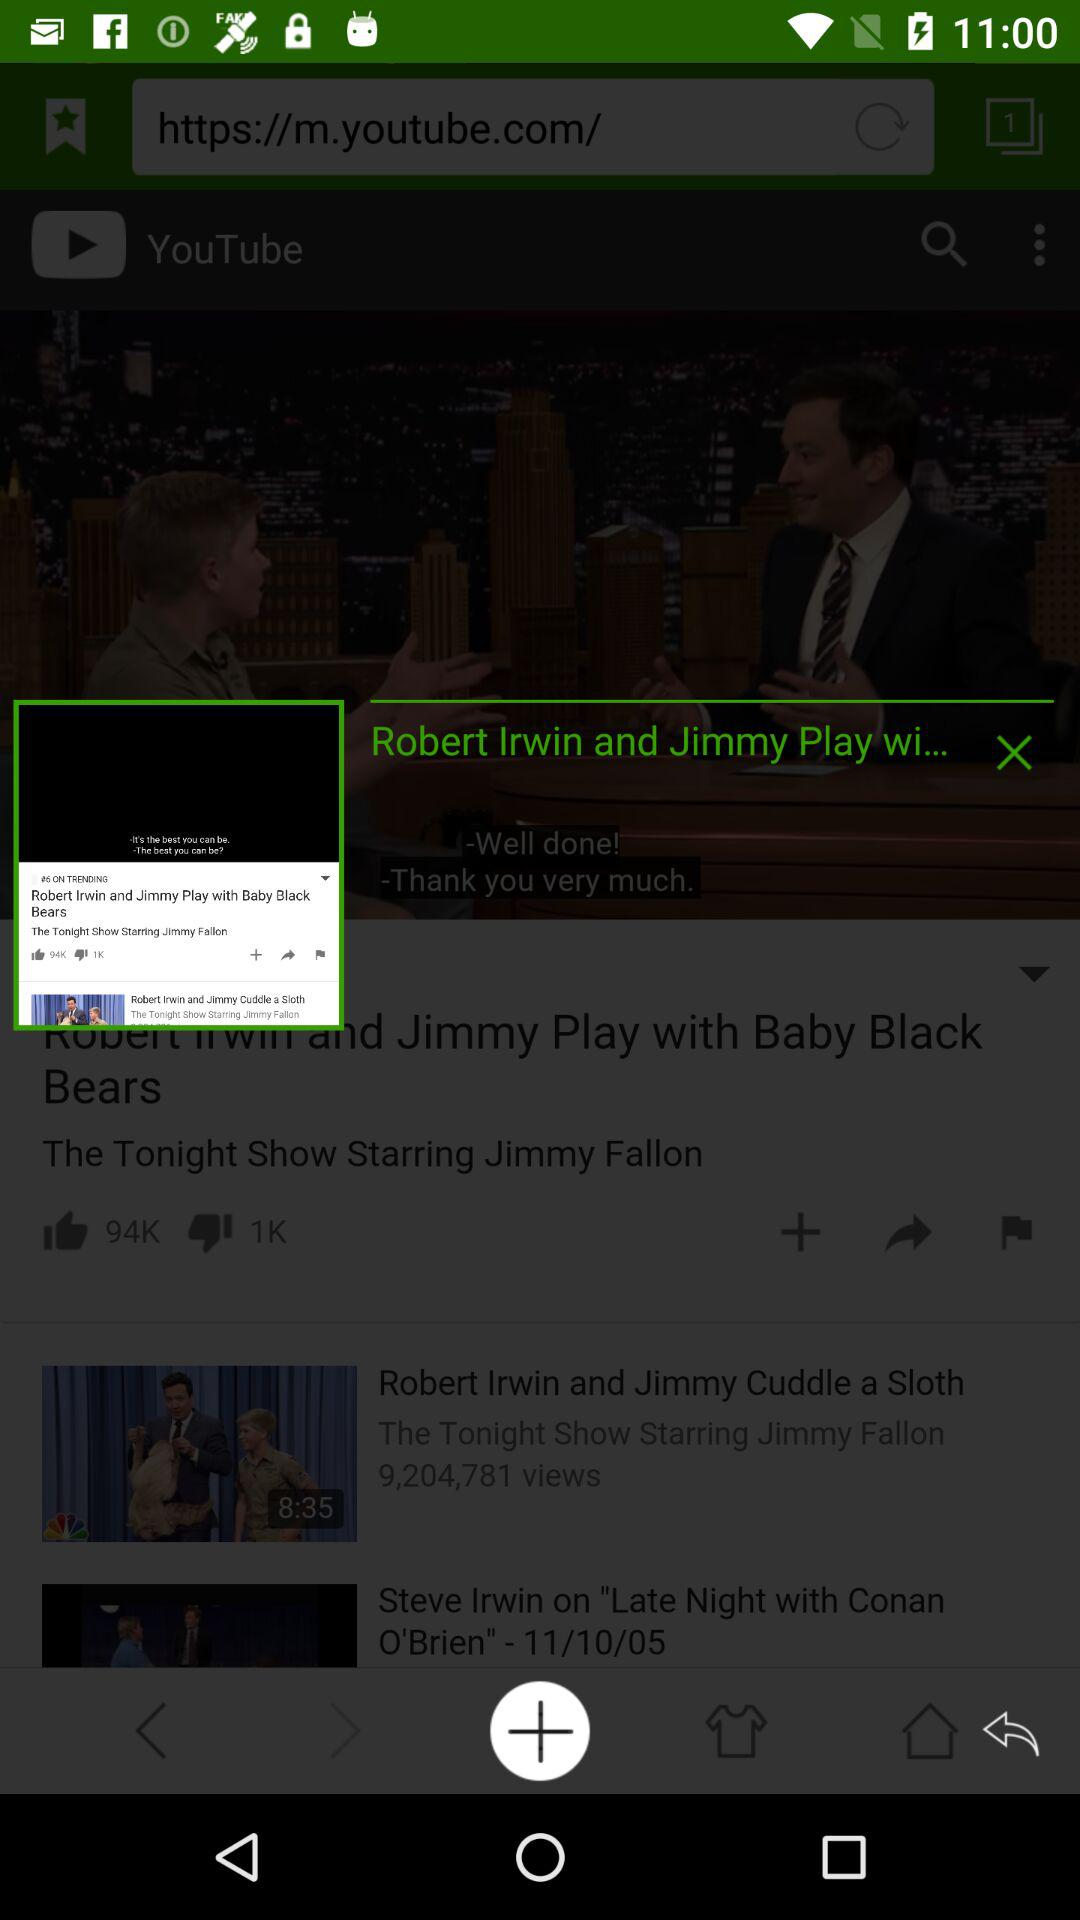How many likes did the video get? The video got 94,000 likes. 